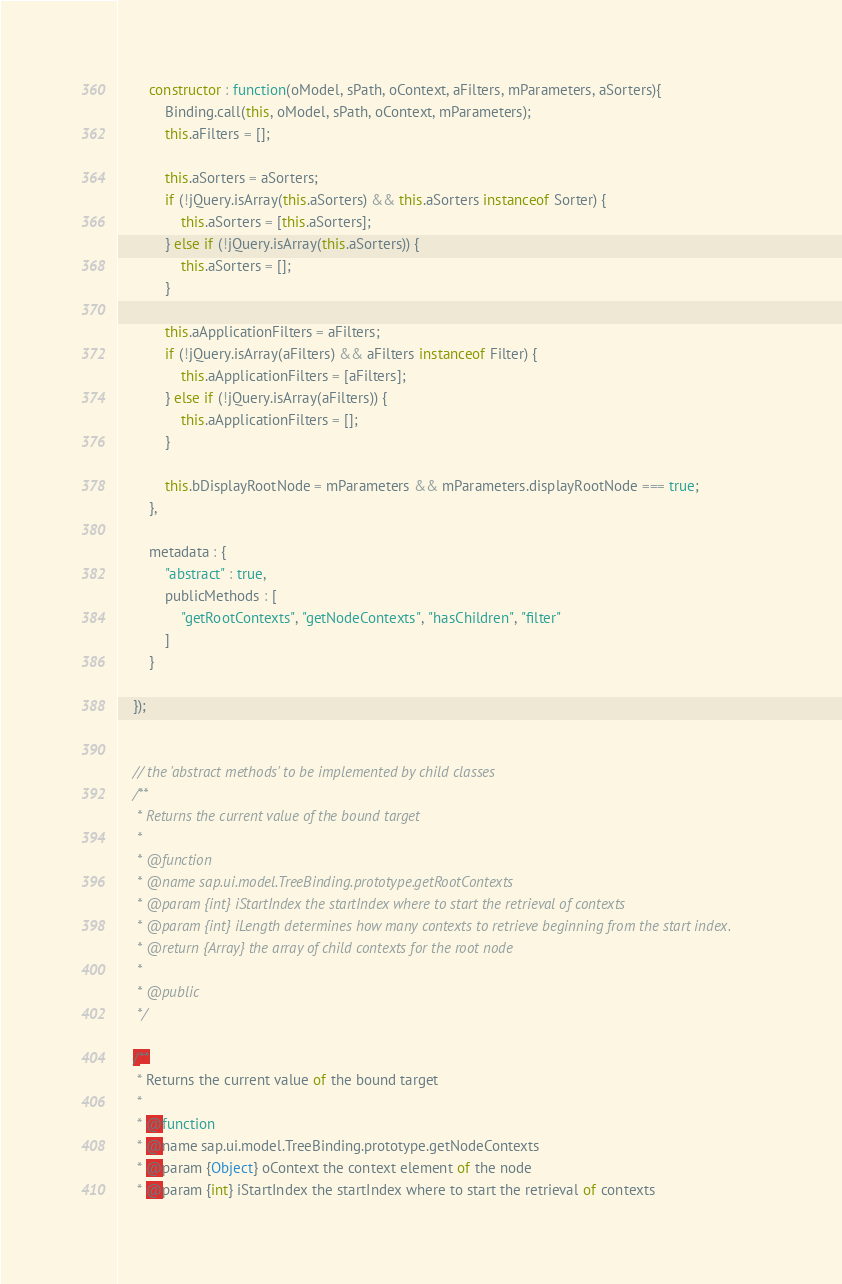Convert code to text. <code><loc_0><loc_0><loc_500><loc_500><_JavaScript_>
		constructor : function(oModel, sPath, oContext, aFilters, mParameters, aSorters){
			Binding.call(this, oModel, sPath, oContext, mParameters);
			this.aFilters = [];

			this.aSorters = aSorters;
			if (!jQuery.isArray(this.aSorters) && this.aSorters instanceof Sorter) {
				this.aSorters = [this.aSorters];
			} else if (!jQuery.isArray(this.aSorters)) {
				this.aSorters = [];
			}

			this.aApplicationFilters = aFilters;
			if (!jQuery.isArray(aFilters) && aFilters instanceof Filter) {
				this.aApplicationFilters = [aFilters];
			} else if (!jQuery.isArray(aFilters)) {
				this.aApplicationFilters = [];
			}

			this.bDisplayRootNode = mParameters && mParameters.displayRootNode === true;
		},

		metadata : {
			"abstract" : true,
			publicMethods : [
				"getRootContexts", "getNodeContexts", "hasChildren", "filter"
			]
		}

	});


	// the 'abstract methods' to be implemented by child classes
	/**
	 * Returns the current value of the bound target
	 *
	 * @function
	 * @name sap.ui.model.TreeBinding.prototype.getRootContexts
	 * @param {int} iStartIndex the startIndex where to start the retrieval of contexts
	 * @param {int} iLength determines how many contexts to retrieve beginning from the start index.
	 * @return {Array} the array of child contexts for the root node
	 *
	 * @public
	 */

	/**
	 * Returns the current value of the bound target
	 *
	 * @function
	 * @name sap.ui.model.TreeBinding.prototype.getNodeContexts
	 * @param {Object} oContext the context element of the node
	 * @param {int} iStartIndex the startIndex where to start the retrieval of contexts</code> 